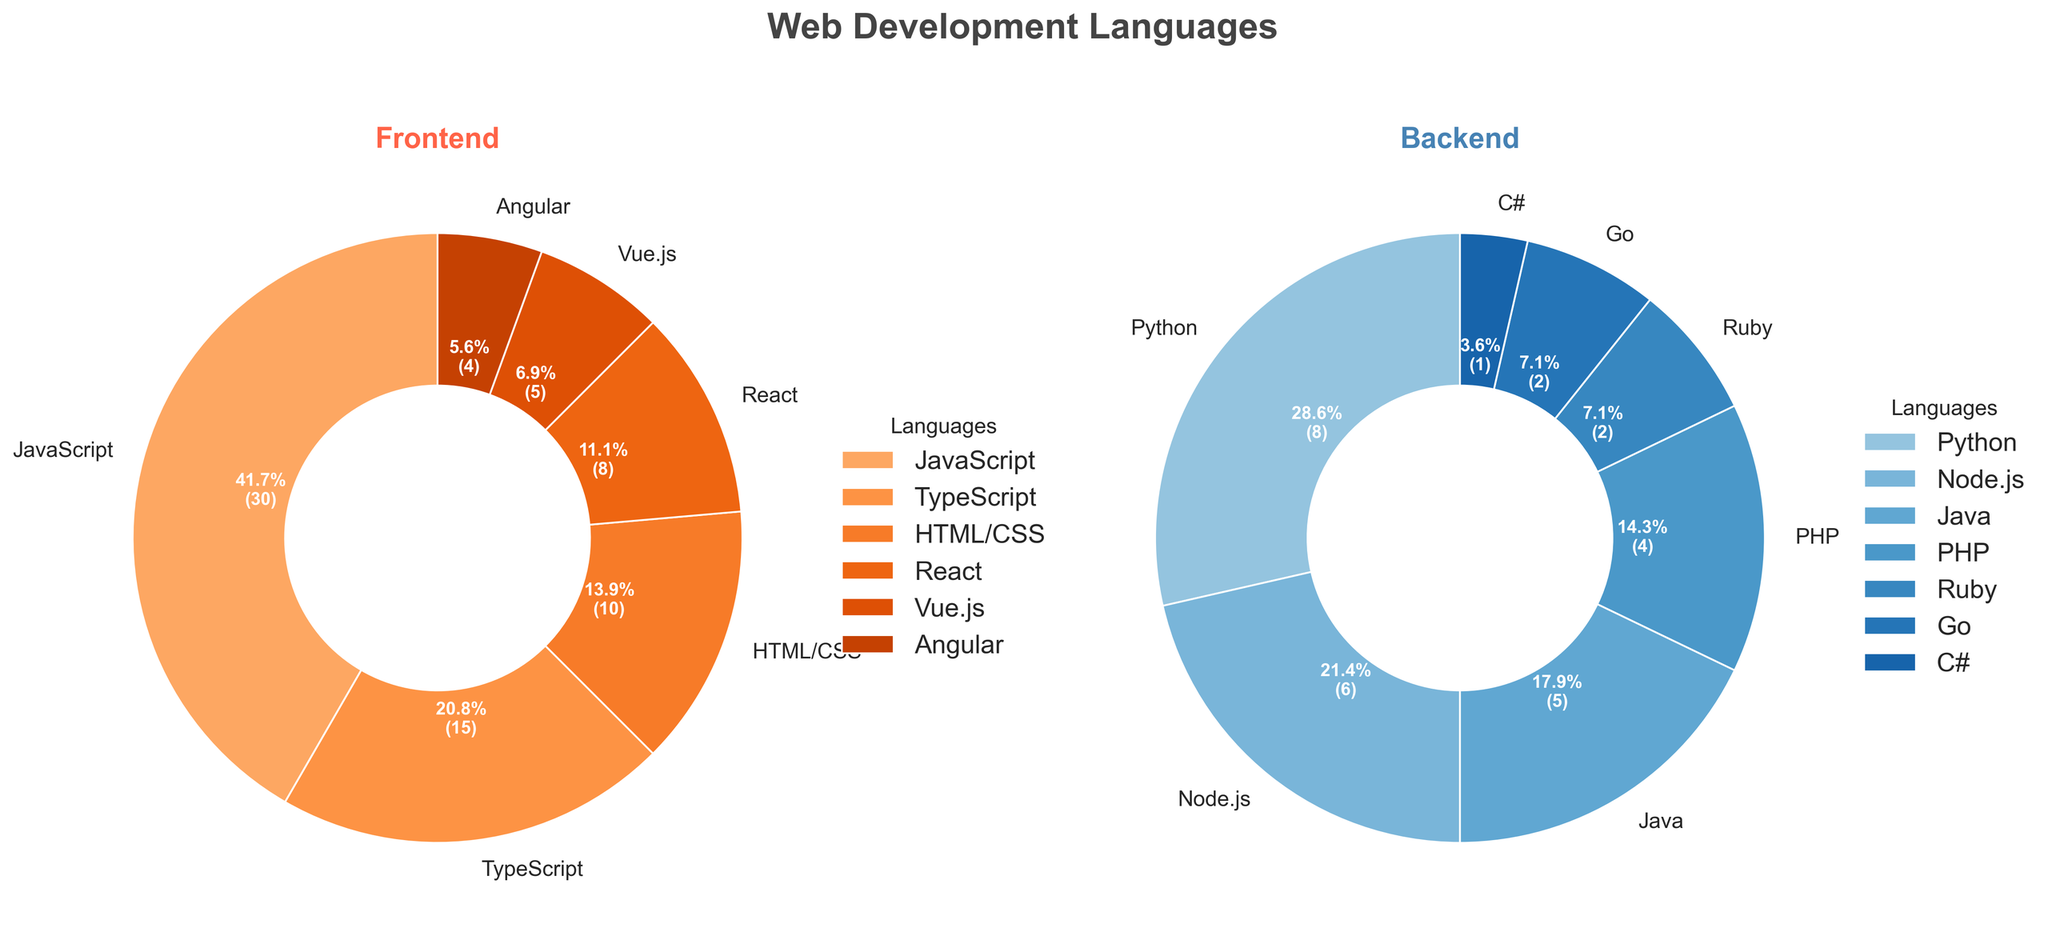What is the total percentage of frontend languages? To find the total percentage of frontend languages, sum up the percentages of JavaScript (30%), TypeScript (15%), HTML/CSS (10%), React (8%), Vue.js (5%), and Angular (4%). 30 + 15 + 10 + 8 + 5 + 4 = 72. The total percentage is 72%.
Answer: 72% Which frontend language has the largest share? By observing the pie chart, JavaScript has the largest slice among the frontend languages with 30%.
Answer: JavaScript Which backend language has the smallest slice in the pie chart? By looking at the backend pie chart, C# has the smallest slice with 1%.
Answer: C# What is the difference in percentage between the largest frontend and backend languages? The largest frontend language is JavaScript (30%). The largest backend language is Python (8%). The difference in their percentages is 30 - 8 = 22%.
Answer: 22% On the backend side, how do the combined percentages of Python and Node.js compare to that of JavaScript alone in the frontend? Python has 8% and Node.js has 6%. Their combined percentage is 8 + 6 = 14%. JavaScript has 30%. Comparatively, 14% is less than 30%.
Answer: Less than Is the total percentage of TypeScript and HTML/CSS together greater than the total percentage of all backend languages combined? TypeScript (15%) and HTML/CSS (10%) together have 15 + 10 = 25%. The backend languages together sum to 8 + 6 + 5 + 4 + 2 + 2 + 1 = 28%. Therefore, 25% is less than 28%.
Answer: No Among the frontend languages, which two have the closest percentage values, and what are their percentages? React (8%) and Vue.js (5%) have the closest percentage values among the frontend languages. The difference is 8 - 5 = 3%.
Answer: React (8%) and Vue.js (5%) Which section of the pie chart has angular wedges on the frontend and backend respectively? The frontend section with angular wedges has Angular with 4%. The backend section with angular wedges has Go and Ruby with 2% each.
Answer: Angular (4%) and Go/Ruby (2% each) How much greater is the percentage of React compared to PHP? React has 8% and PHP has 4%, so the difference is 8 - 4 = 4%.
Answer: 4% What is the combined percentage of Java and PHP? Java has 5% and PHP has 4%, so their combined percentage is 5 + 4 = 9%.
Answer: 9% 